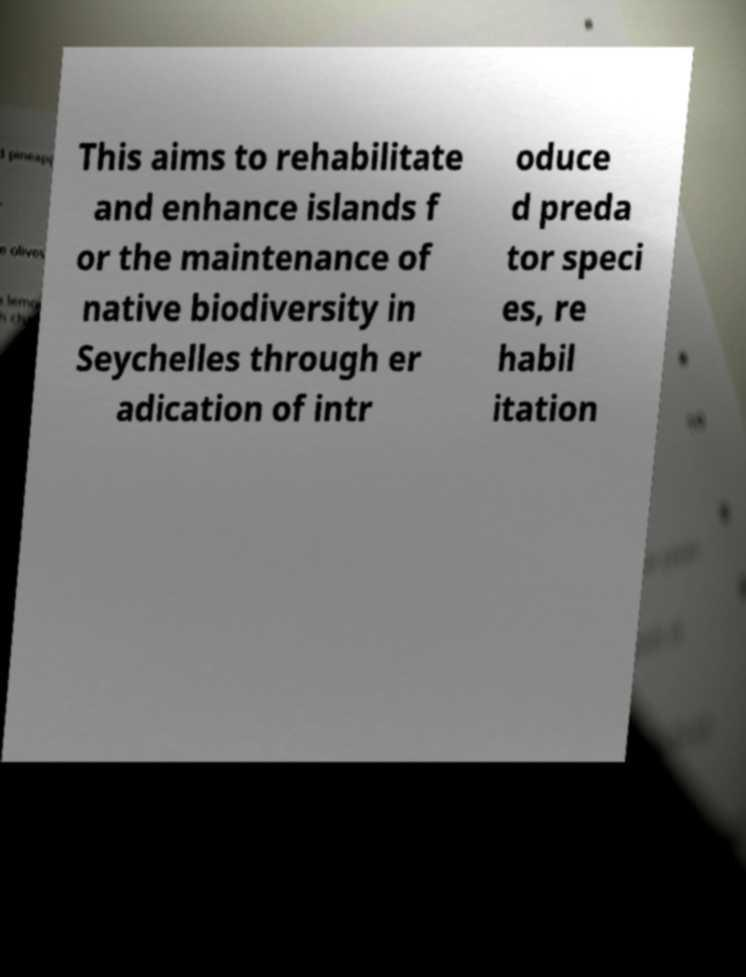Please identify and transcribe the text found in this image. This aims to rehabilitate and enhance islands f or the maintenance of native biodiversity in Seychelles through er adication of intr oduce d preda tor speci es, re habil itation 